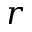<formula> <loc_0><loc_0><loc_500><loc_500>r</formula> 